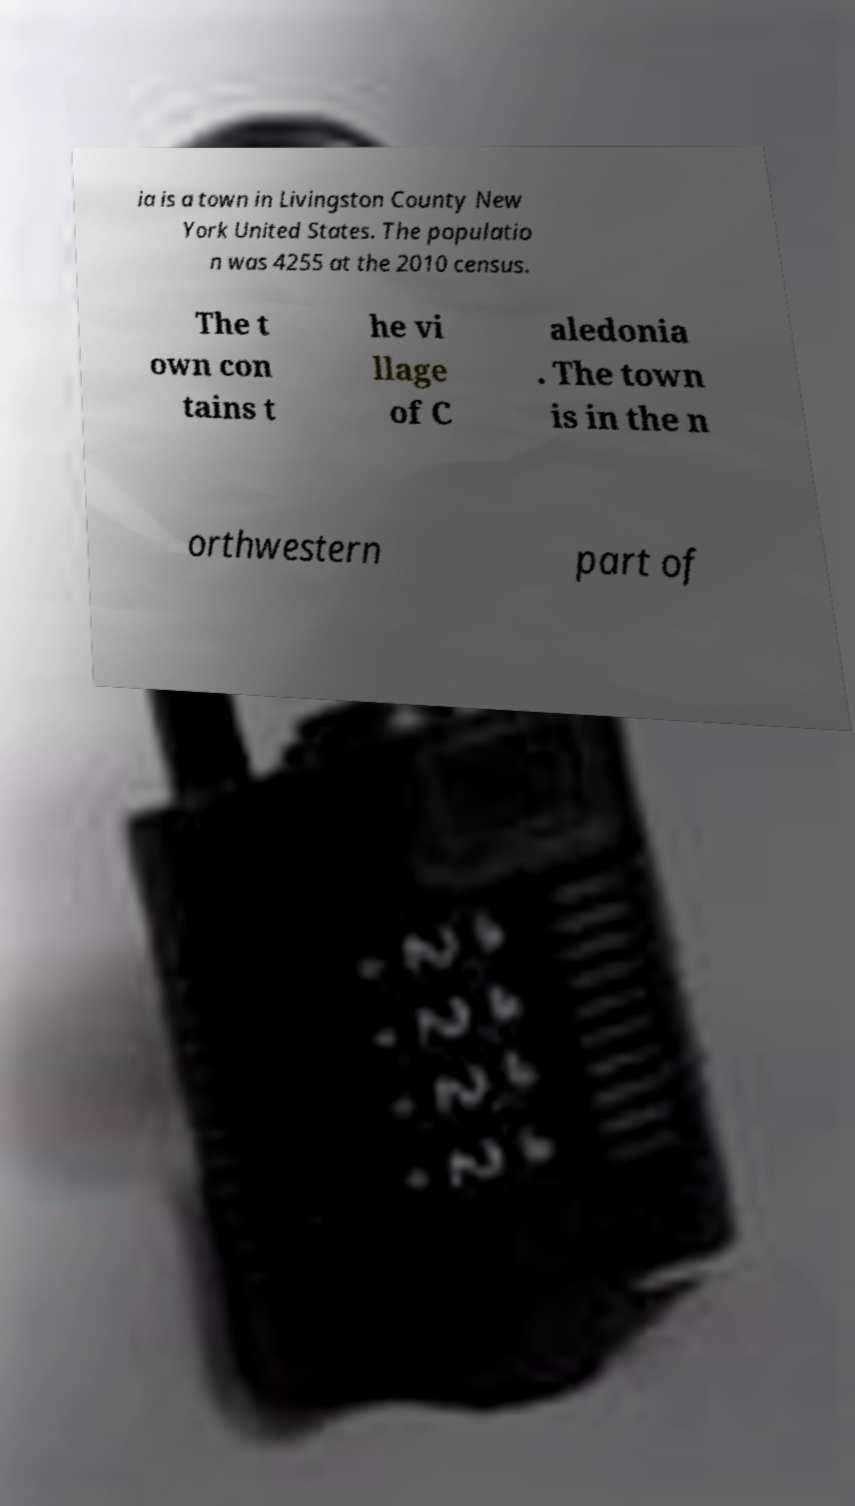I need the written content from this picture converted into text. Can you do that? ia is a town in Livingston County New York United States. The populatio n was 4255 at the 2010 census. The t own con tains t he vi llage of C aledonia . The town is in the n orthwestern part of 